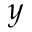<formula> <loc_0><loc_0><loc_500><loc_500>y</formula> 